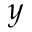<formula> <loc_0><loc_0><loc_500><loc_500>y</formula> 